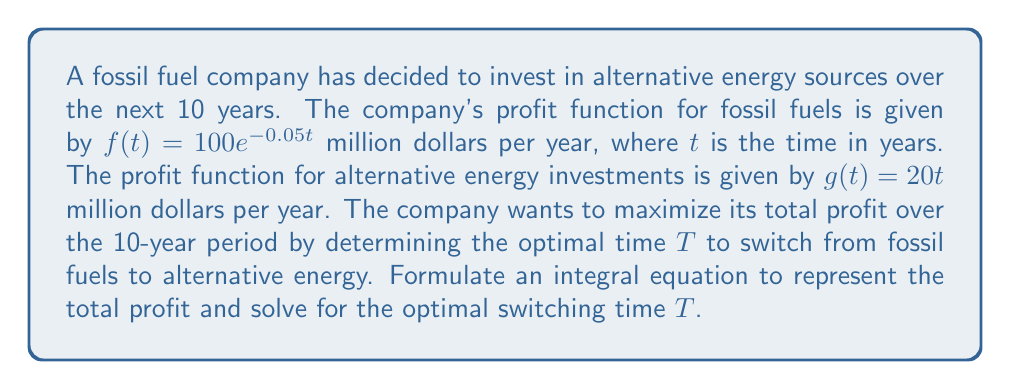Solve this math problem. To solve this problem, we'll follow these steps:

1) The total profit over 10 years is the sum of profits from fossil fuels (from 0 to T) and alternative energy (from T to 10).

2) We can represent this as an integral equation:

   $$P(T) = \int_0^T 100e^{-0.05t} dt + \int_T^{10} 20t dt$$

3) To find the optimal T, we need to maximize P(T). We can do this by differentiating P(T) with respect to T and setting it to zero.

4) First, let's solve the integrals:

   $$P(T) = [-2000e^{-0.05t}]_0^T + [10t^2]_T^{10}$$
   $$P(T) = -2000e^{-0.05T} + 2000 + 1000 - 10T^2$$
   $$P(T) = 3000 - 2000e^{-0.05T} - 10T^2$$

5) Now, let's differentiate P(T) with respect to T:

   $$\frac{dP}{dT} = 100e^{-0.05T} - 20T$$

6) Set this equal to zero and solve for T:

   $$100e^{-0.05T} - 20T = 0$$
   $$5e^{-0.05T} = T$$

7) This equation can't be solved algebraically. We need to use numerical methods or graphical solutions. Using a graphing calculator or computer software, we find that the solution is approximately:

   $$T \approx 6.43$$

8) We should verify that this is a maximum by checking the second derivative is negative at this point.
Answer: The optimal switching time is approximately 6.43 years. 